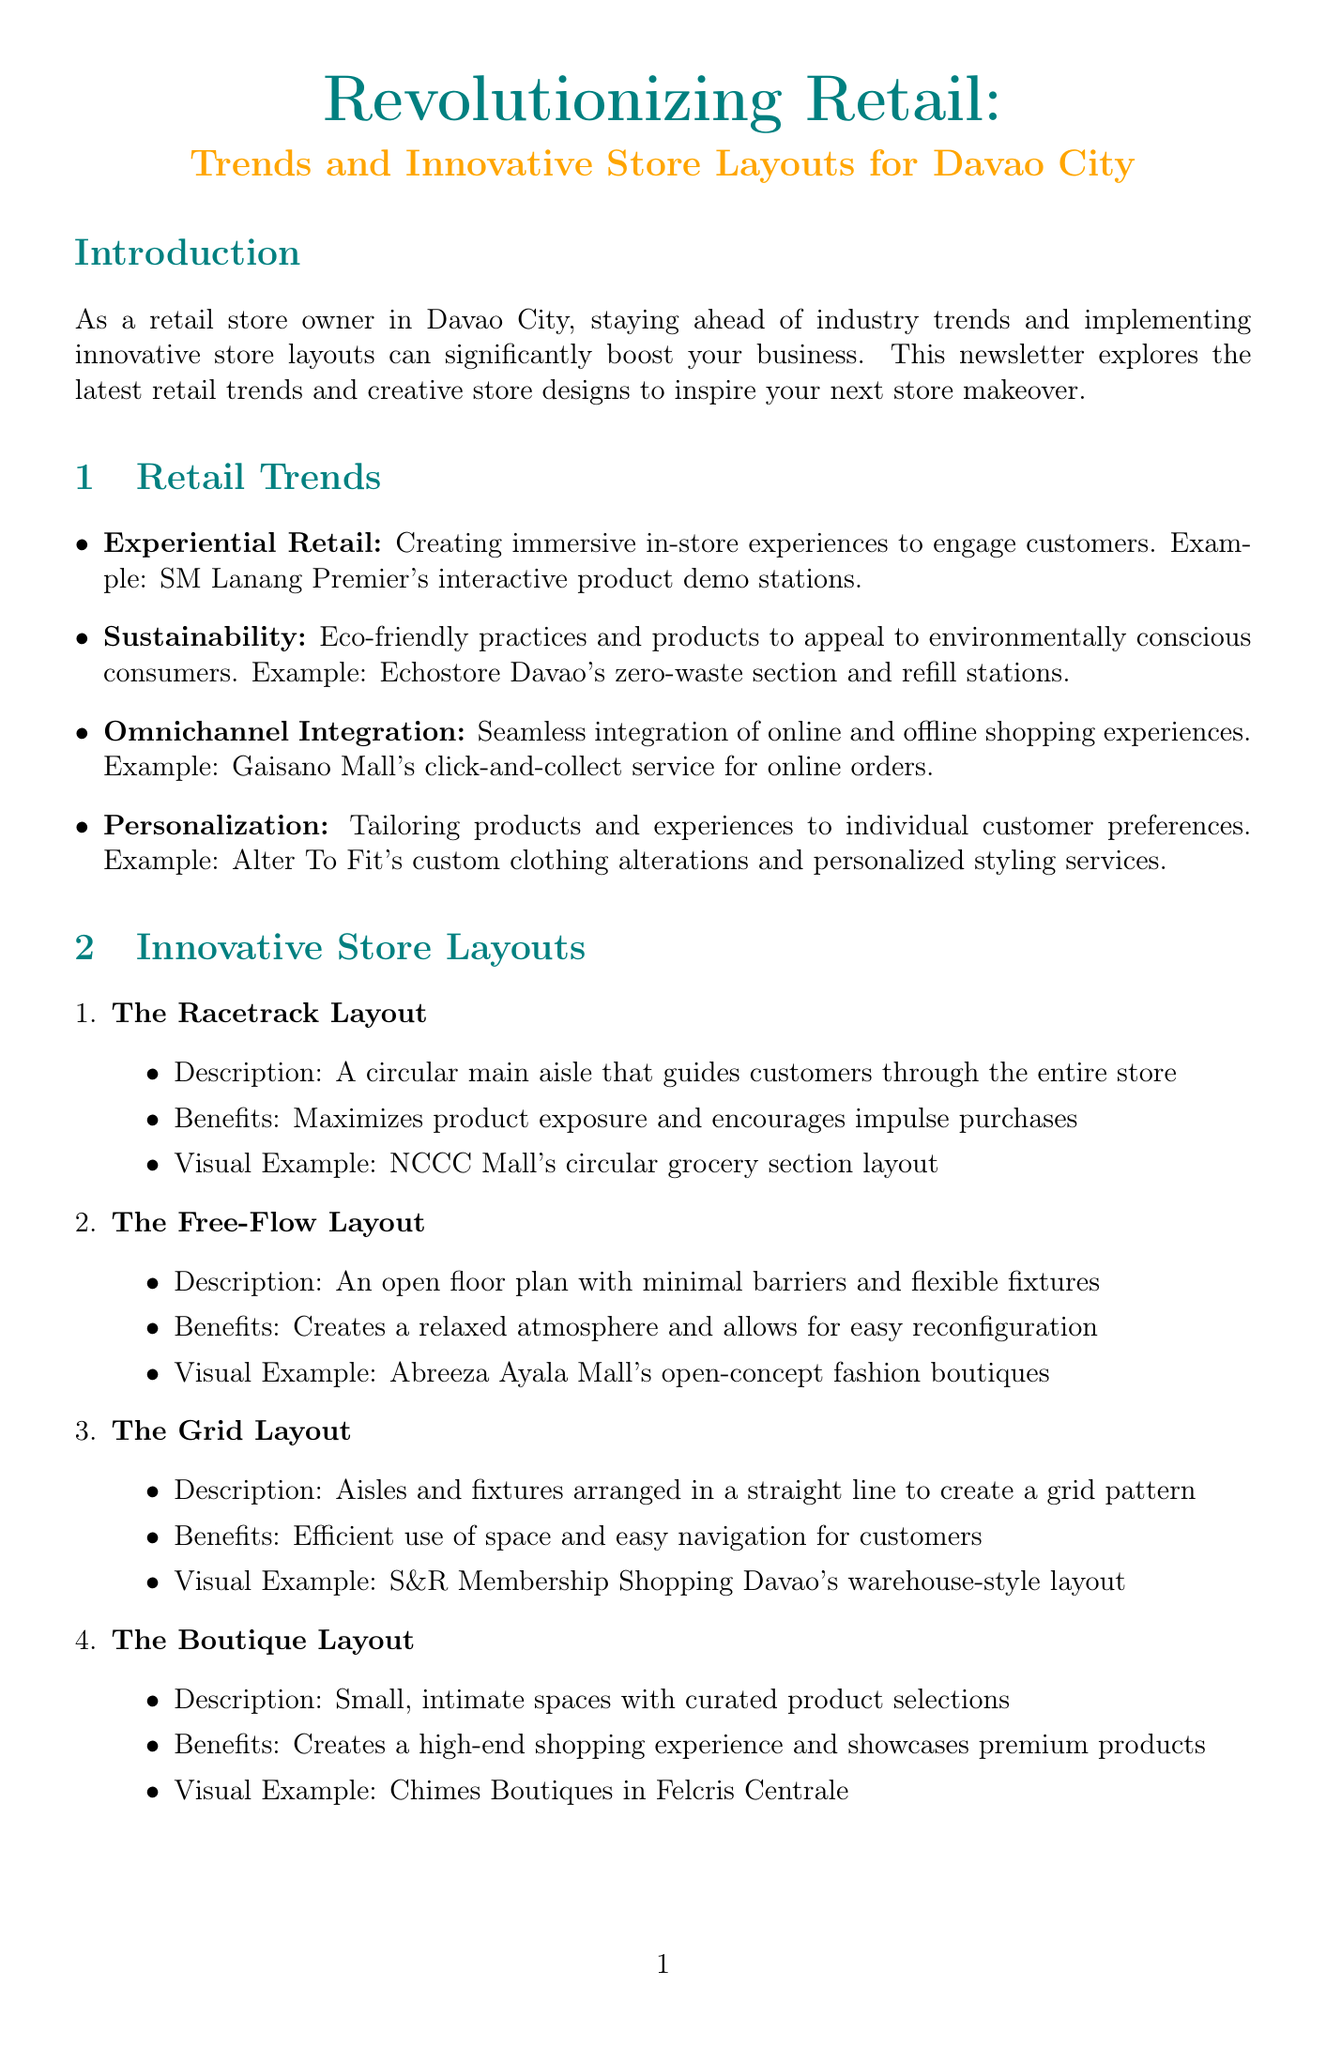What is the title of the newsletter? The title of the newsletter is specified at the top of the document.
Answer: Revolutionizing Retail: Trends and Innovative Store Layouts for Davao City What layout maximizes product exposure? The Racetrack Layout is mentioned as maximizing product exposure and encouraging impulse purchases.
Answer: The Racetrack Layout What was the percentage increase in foot traffic at Davao Souvenir Central? The document states the results achieved by Davao Souvenir Central after the layout changes.
Answer: 30% Which retail trend focuses on eco-friendly practices? The trend of Sustainability emphasizes eco-friendly practices and products to appeal to consumers.
Answer: Sustainability What type of store layout is described as creating a relaxed atmosphere? The Free-Flow Layout is defined in the document as creating a relaxed atmosphere.
Answer: The Free-Flow Layout Which local store implemented a mix of grid and free-flow layouts? The document provides a case study about a local store that implemented these layouts successfully.
Answer: Davao Souvenir Central What is an example of an experiential retail feature? The document lists specific examples of experiential retail, focusing on engaging customers in-store.
Answer: SM Lanang Premier's interactive product demo stations What layout is characterized by small, intimate spaces? According to the document, a layout that features small, intimate spaces is the Boutique Layout.
Answer: The Boutique Layout 